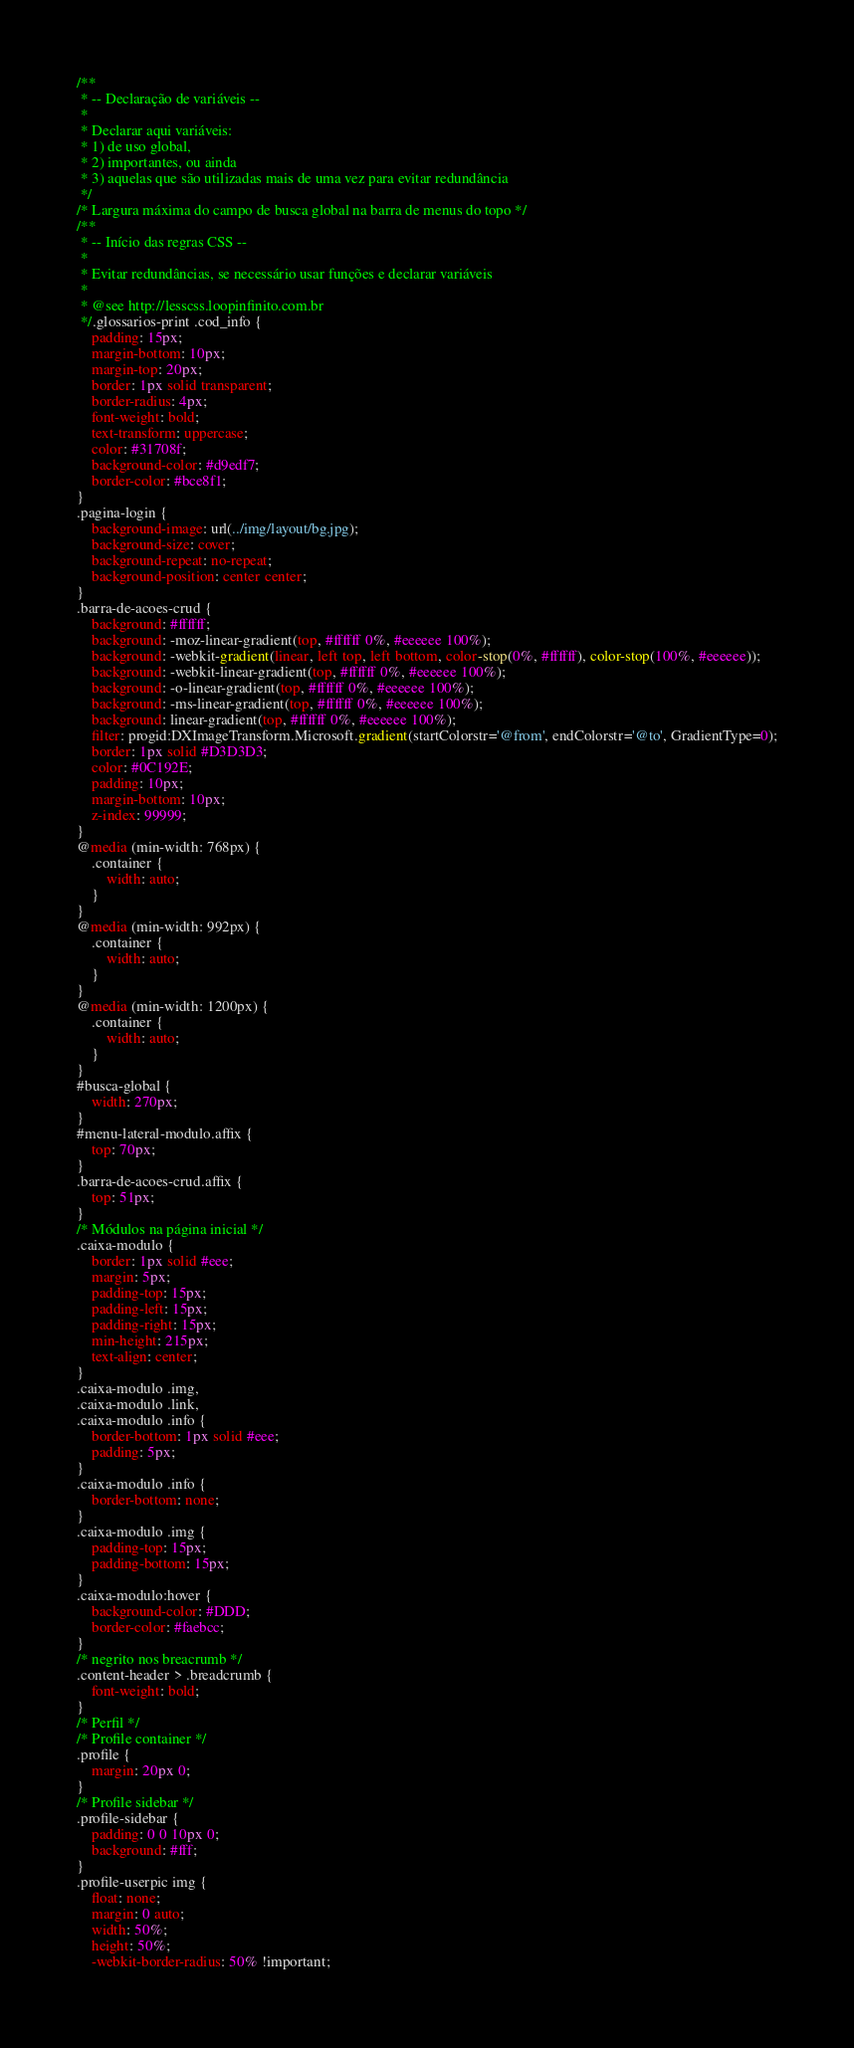<code> <loc_0><loc_0><loc_500><loc_500><_CSS_>/**
 * -- Declaração de variáveis --
 *
 * Declarar aqui variáveis: 
 * 1) de uso global, 
 * 2) importantes, ou ainda
 * 3) aquelas que são utilizadas mais de uma vez para evitar redundância
 */
/* Largura máxima do campo de busca global na barra de menus do topo */
/**
 * -- Início das regras CSS --
 *
 * Evitar redundâncias, se necessário usar funções e declarar variáveis
 *
 * @see http://lesscss.loopinfinito.com.br
 */.glossarios-print .cod_info {
    padding: 15px;
    margin-bottom: 10px;
    margin-top: 20px;
    border: 1px solid transparent;
    border-radius: 4px;
    font-weight: bold;
    text-transform: uppercase;
    color: #31708f;
    background-color: #d9edf7;
    border-color: #bce8f1;
}
.pagina-login {
    background-image: url(../img/layout/bg.jpg);
    background-size: cover;
    background-repeat: no-repeat;
    background-position: center center;
}
.barra-de-acoes-crud {
    background: #ffffff;
    background: -moz-linear-gradient(top, #ffffff 0%, #eeeeee 100%);
    background: -webkit-gradient(linear, left top, left bottom, color-stop(0%, #ffffff), color-stop(100%, #eeeeee));
    background: -webkit-linear-gradient(top, #ffffff 0%, #eeeeee 100%);
    background: -o-linear-gradient(top, #ffffff 0%, #eeeeee 100%);
    background: -ms-linear-gradient(top, #ffffff 0%, #eeeeee 100%);
    background: linear-gradient(top, #ffffff 0%, #eeeeee 100%);
    filter: progid:DXImageTransform.Microsoft.gradient(startColorstr='@from', endColorstr='@to', GradientType=0);
    border: 1px solid #D3D3D3;
    color: #0C192E;
    padding: 10px;
    margin-bottom: 10px;
    z-index: 99999;
}
@media (min-width: 768px) {
    .container {
        width: auto;
    }
}
@media (min-width: 992px) {
    .container {
        width: auto;
    }
}
@media (min-width: 1200px) {
    .container {
        width: auto;
    }
}
#busca-global {
    width: 270px;
}
#menu-lateral-modulo.affix {
    top: 70px;
}
.barra-de-acoes-crud.affix {
    top: 51px;
}
/* Módulos na página inicial */
.caixa-modulo {
    border: 1px solid #eee;
    margin: 5px;
    padding-top: 15px;
    padding-left: 15px;
    padding-right: 15px;
    min-height: 215px;
    text-align: center;
}
.caixa-modulo .img,
.caixa-modulo .link,
.caixa-modulo .info {
    border-bottom: 1px solid #eee;
    padding: 5px;
}
.caixa-modulo .info {
    border-bottom: none;
}
.caixa-modulo .img {
    padding-top: 15px;
    padding-bottom: 15px;
}
.caixa-modulo:hover {
    background-color: #DDD;
    border-color: #faebcc;
}
/* negrito nos breacrumb */
.content-header > .breadcrumb {
    font-weight: bold;
}
/* Perfil */
/* Profile container */
.profile {
    margin: 20px 0;
}
/* Profile sidebar */
.profile-sidebar {
    padding: 0 0 10px 0;
    background: #fff;
}
.profile-userpic img {
    float: none;
    margin: 0 auto;
    width: 50%;
    height: 50%;
    -webkit-border-radius: 50% !important;</code> 